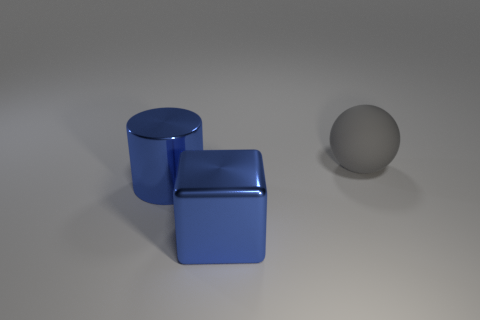What is the texture like on the blue objects? The blue objects in the image have a smooth and reflective texture, suggesting they are likely made of a polished material. 